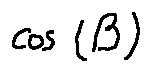<formula> <loc_0><loc_0><loc_500><loc_500>\cos ( \beta )</formula> 